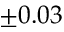Convert formula to latex. <formula><loc_0><loc_0><loc_500><loc_500>\pm 0 . 0 3</formula> 